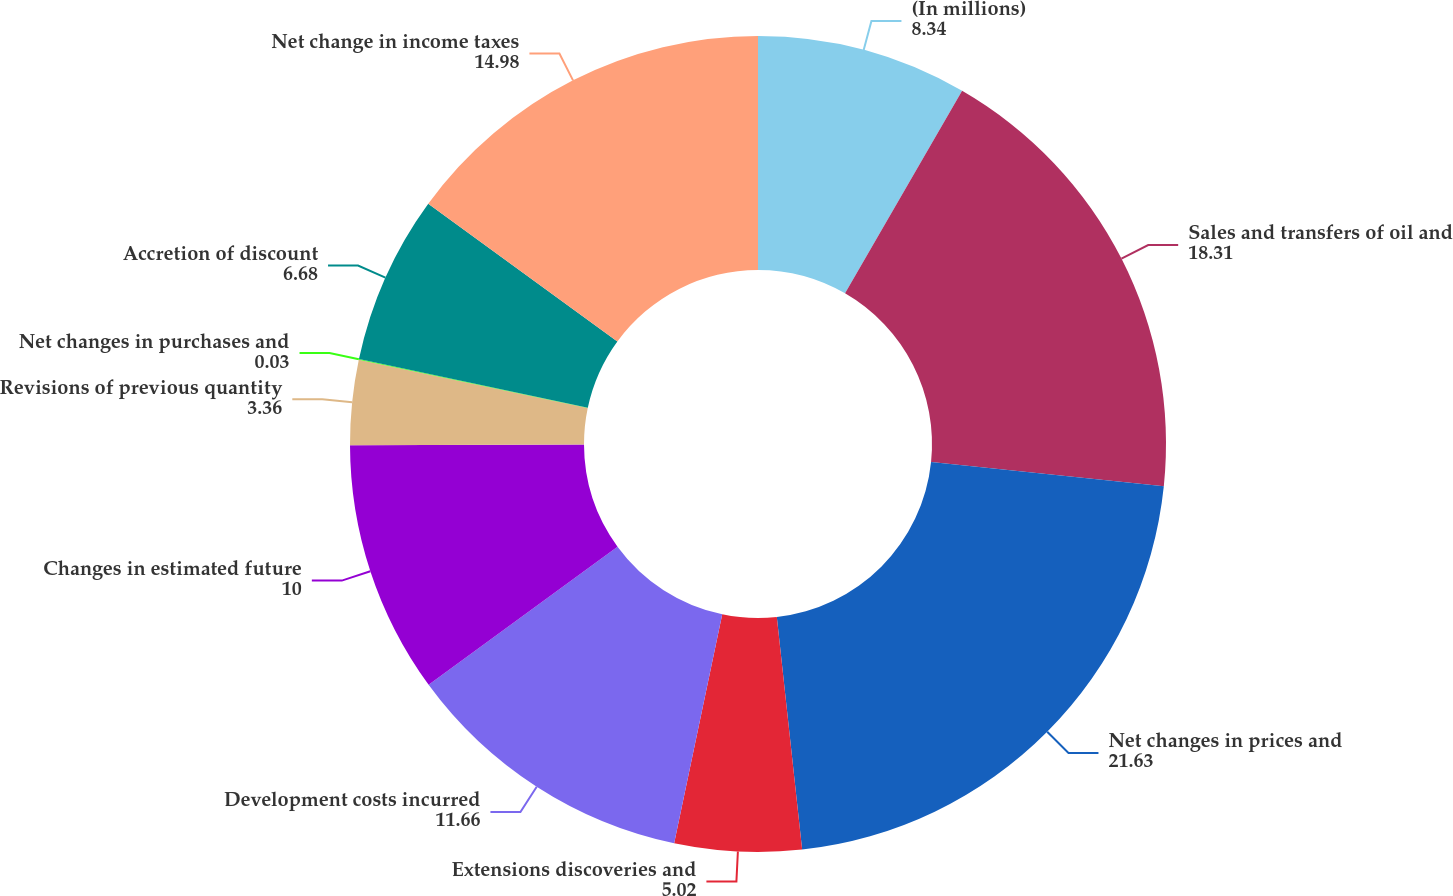Convert chart. <chart><loc_0><loc_0><loc_500><loc_500><pie_chart><fcel>(In millions)<fcel>Sales and transfers of oil and<fcel>Net changes in prices and<fcel>Extensions discoveries and<fcel>Development costs incurred<fcel>Changes in estimated future<fcel>Revisions of previous quantity<fcel>Net changes in purchases and<fcel>Accretion of discount<fcel>Net change in income taxes<nl><fcel>8.34%<fcel>18.31%<fcel>21.63%<fcel>5.02%<fcel>11.66%<fcel>10.0%<fcel>3.36%<fcel>0.03%<fcel>6.68%<fcel>14.98%<nl></chart> 